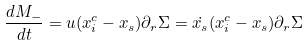Convert formula to latex. <formula><loc_0><loc_0><loc_500><loc_500>\frac { d M _ { - } } { d t } = u ( x _ { i } ^ { c } - x _ { s } ) \partial _ { r } \Sigma = \dot { x _ { s } } ( x _ { i } ^ { c } - x _ { s } ) \partial _ { r } \Sigma</formula> 